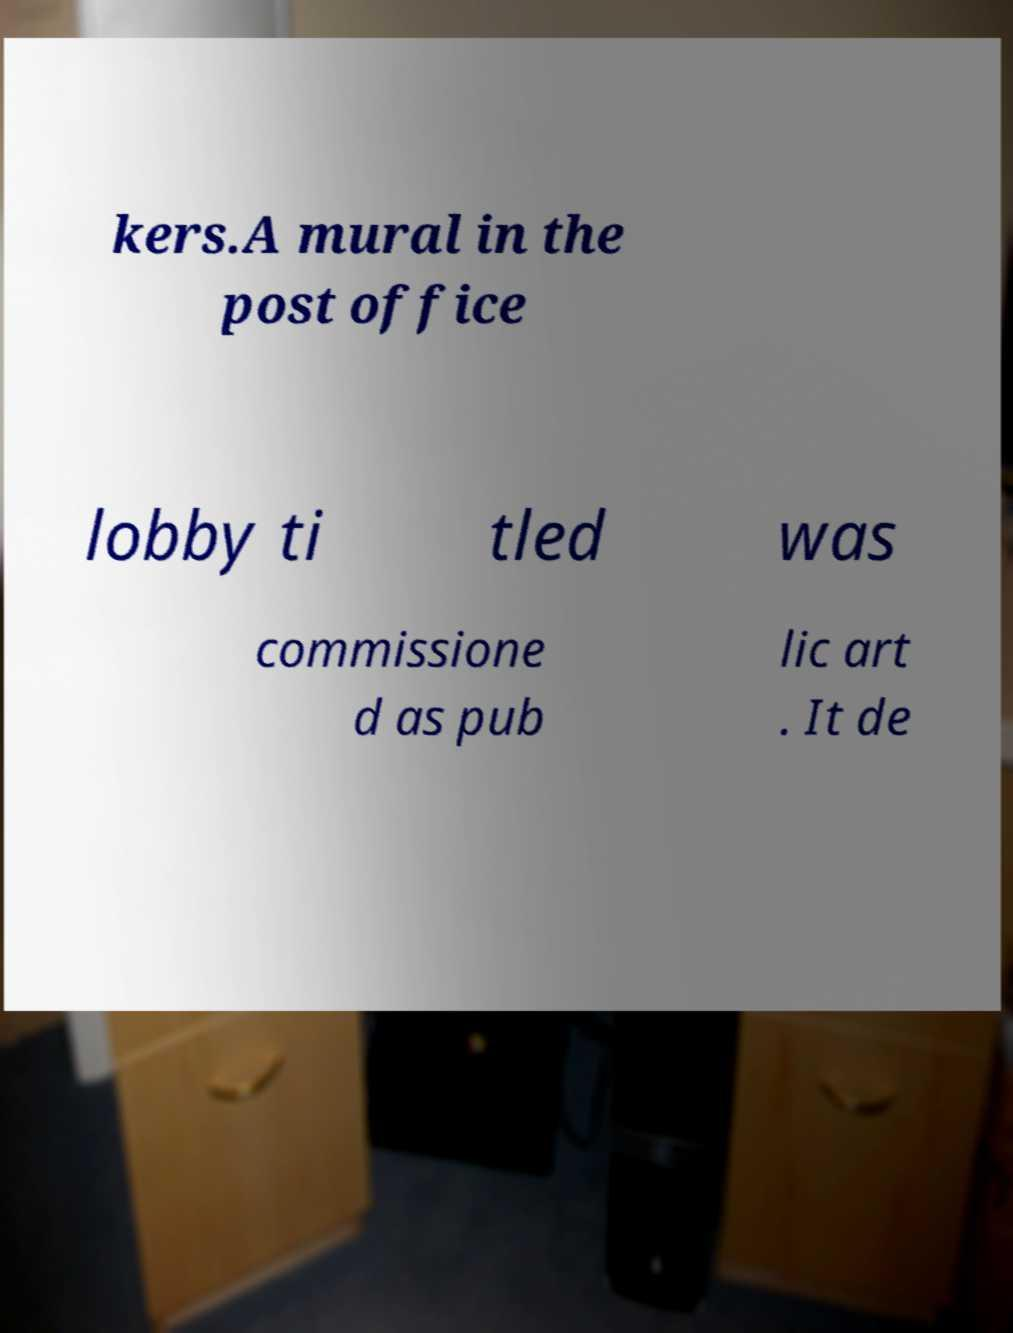I need the written content from this picture converted into text. Can you do that? kers.A mural in the post office lobby ti tled was commissione d as pub lic art . It de 